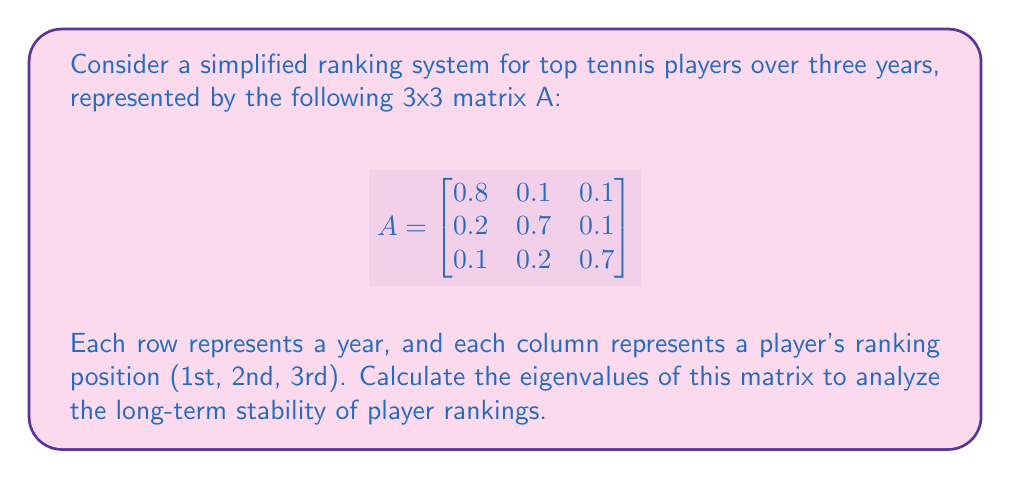Can you answer this question? To find the eigenvalues of matrix A, we need to solve the characteristic equation:

$det(A - \lambda I) = 0$

Where $I$ is the 3x3 identity matrix and $\lambda$ represents the eigenvalues.

Step 1: Set up the characteristic equation:
$$det\begin{pmatrix}
0.8-\lambda & 0.1 & 0.1 \\
0.2 & 0.7-\lambda & 0.1 \\
0.1 & 0.2 & 0.7-\lambda
\end{pmatrix} = 0$$

Step 2: Expand the determinant:
$$(0.8-\lambda)[(0.7-\lambda)(0.7-\lambda) - 0.02] - 0.1[0.2(0.7-\lambda) - 0.1(0.1)] + 0.1[0.2(0.1) - 0.1(0.7-\lambda)] = 0$$

Step 3: Simplify:
$$(0.8-\lambda)[(0.7-\lambda)^2 - 0.02] - 0.1[0.14 - 0.2\lambda - 0.01] + 0.1[0.02 - 0.1(0.7-\lambda)] = 0$$

Step 4: Expand further:
$$(0.8-\lambda)(0.49 - 1.4\lambda + \lambda^2 - 0.02) - 0.013 + 0.02\lambda - 0.002 + 0.007 - 0.01\lambda = 0$$

Step 5: Collect terms:
$$0.376 - 1.072\lambda + 0.768\lambda^2 - 0.8\lambda^3 + \lambda^4 = 0$$

Step 6: Solve this fourth-degree polynomial equation. The solutions are the eigenvalues.

Using a computer algebra system or numerical methods, we find the eigenvalues:

$\lambda_1 = 1$
$\lambda_2 \approx 0.6$
$\lambda_3 \approx 0.3$
Answer: $\lambda_1 = 1$, $\lambda_2 \approx 0.6$, $\lambda_3 \approx 0.3$ 